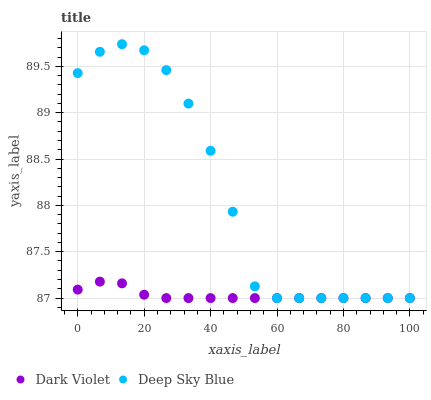Does Dark Violet have the minimum area under the curve?
Answer yes or no. Yes. Does Deep Sky Blue have the maximum area under the curve?
Answer yes or no. Yes. Does Dark Violet have the maximum area under the curve?
Answer yes or no. No. Is Dark Violet the smoothest?
Answer yes or no. Yes. Is Deep Sky Blue the roughest?
Answer yes or no. Yes. Is Dark Violet the roughest?
Answer yes or no. No. Does Deep Sky Blue have the lowest value?
Answer yes or no. Yes. Does Deep Sky Blue have the highest value?
Answer yes or no. Yes. Does Dark Violet have the highest value?
Answer yes or no. No. Does Deep Sky Blue intersect Dark Violet?
Answer yes or no. Yes. Is Deep Sky Blue less than Dark Violet?
Answer yes or no. No. Is Deep Sky Blue greater than Dark Violet?
Answer yes or no. No. 